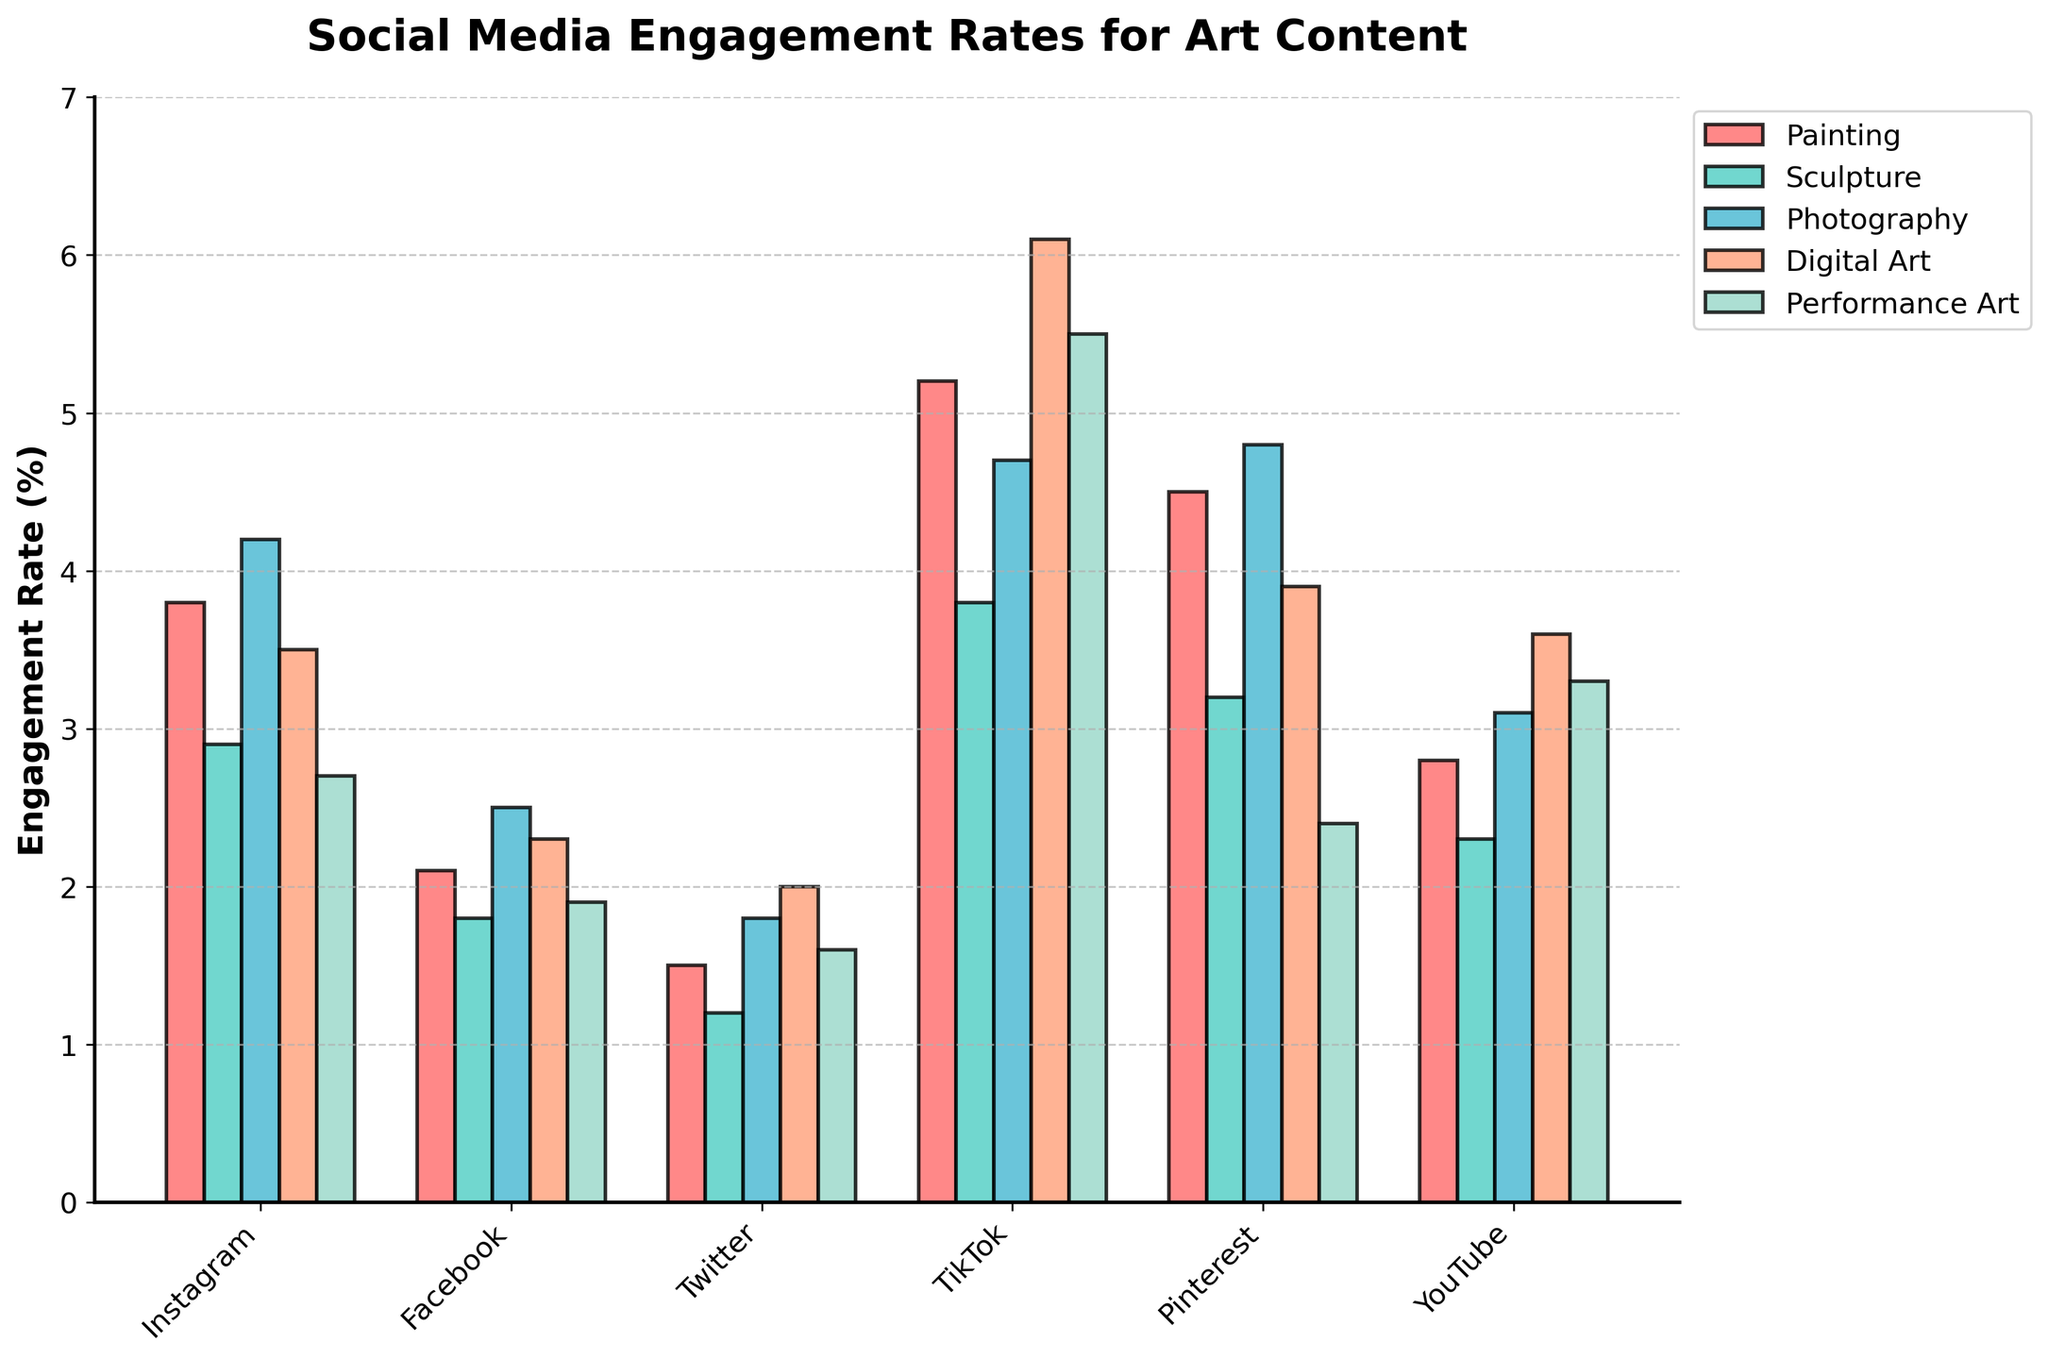What platform has the highest engagement rate for Digital Art? First, locate the Digital Art bars, which are colored in a specific shade. Check the height of these bars across all platforms. TikTok has the highest bar for Digital Art with an engagement rate of 6.1%.
Answer: TikTok How does the engagement rate of Photography on Instagram compare to TikTok? Find the Photography bars, then check their heights for Instagram and TikTok. Instagram's Photography engagement rate is 4.2%, while TikTok's is 4.7%.
Answer: TikTok is higher Which type of art content has the lowest average engagement rate across all platforms? Calculate the average engagement rate for each type of art content by adding up the values for each platform and dividing by the number of platforms. Performance Art has the lowest average.
Answer: Performance Art Among the platforms, where does YouTube rank in terms of engagement rate for Painting? Compare the Painting bars on each platform. YouTube's Painting engagement rate is 2.8%, which places it behind Instagram (3.8%) and Pinterest (4.5%), but ahead of Twitter (1.5%) and Facebook (2.1%).
Answer: 3rd highest What is the combined engagement rate of Sculpture on Facebook and Twitter? Locate the engagement rate for Sculpture on both Facebook and Twitter. Add these two values: 1.8% (Facebook) + 1.2% (Twitter) = 3.0%.
Answer: 3.0% How does the engagement rate of Performance Art on Pinterest compare to other platforms? Check the height of the Performance Art bars on each platform. Performance Art's engagement rate on Pinterest is 2.4%, which is lower than TikTok (5.5%), YouTube (3.3%), and Digital Art on Instagram, Facebook, and Twitter too.
Answer: Lower If you sum the engagement rates for Painting across Instagram, Facebook, Twitter, and TikTok, what do you get? Add the Painting engagement rates for Instagram (3.8%), Facebook (2.1%), Twitter (1.5%), and TikTok (5.2%): 3.8 + 2.1 + 1.5 + 5.2 = 12.6
Answer: 12.6 Which platform has the most consistent engagement rates across all content types? Examine the height of the bars across all platforms to see which platform has bars of similar height. Facebook appears most consistent, with engagement rates ranging from 1.8% to 2.5%.
Answer: Facebook 